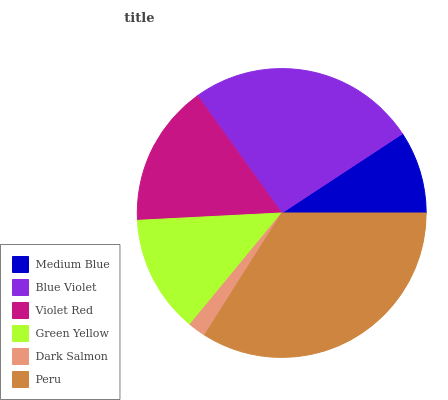Is Dark Salmon the minimum?
Answer yes or no. Yes. Is Peru the maximum?
Answer yes or no. Yes. Is Blue Violet the minimum?
Answer yes or no. No. Is Blue Violet the maximum?
Answer yes or no. No. Is Blue Violet greater than Medium Blue?
Answer yes or no. Yes. Is Medium Blue less than Blue Violet?
Answer yes or no. Yes. Is Medium Blue greater than Blue Violet?
Answer yes or no. No. Is Blue Violet less than Medium Blue?
Answer yes or no. No. Is Violet Red the high median?
Answer yes or no. Yes. Is Green Yellow the low median?
Answer yes or no. Yes. Is Green Yellow the high median?
Answer yes or no. No. Is Violet Red the low median?
Answer yes or no. No. 